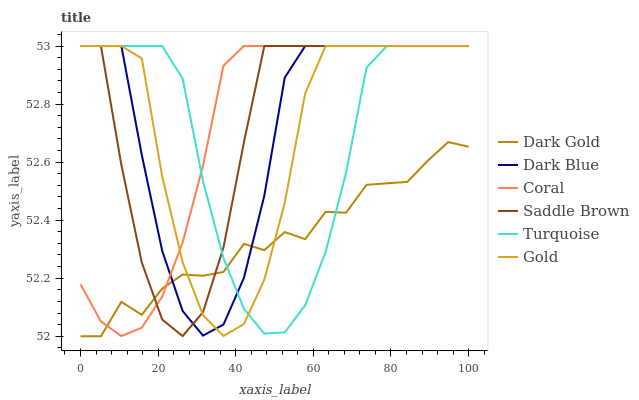Does Dark Gold have the minimum area under the curve?
Answer yes or no. Yes. Does Saddle Brown have the maximum area under the curve?
Answer yes or no. Yes. Does Gold have the minimum area under the curve?
Answer yes or no. No. Does Gold have the maximum area under the curve?
Answer yes or no. No. Is Coral the smoothest?
Answer yes or no. Yes. Is Gold the roughest?
Answer yes or no. Yes. Is Dark Gold the smoothest?
Answer yes or no. No. Is Dark Gold the roughest?
Answer yes or no. No. Does Dark Gold have the lowest value?
Answer yes or no. Yes. Does Gold have the lowest value?
Answer yes or no. No. Does Saddle Brown have the highest value?
Answer yes or no. Yes. Does Dark Gold have the highest value?
Answer yes or no. No. Does Saddle Brown intersect Gold?
Answer yes or no. Yes. Is Saddle Brown less than Gold?
Answer yes or no. No. Is Saddle Brown greater than Gold?
Answer yes or no. No. 